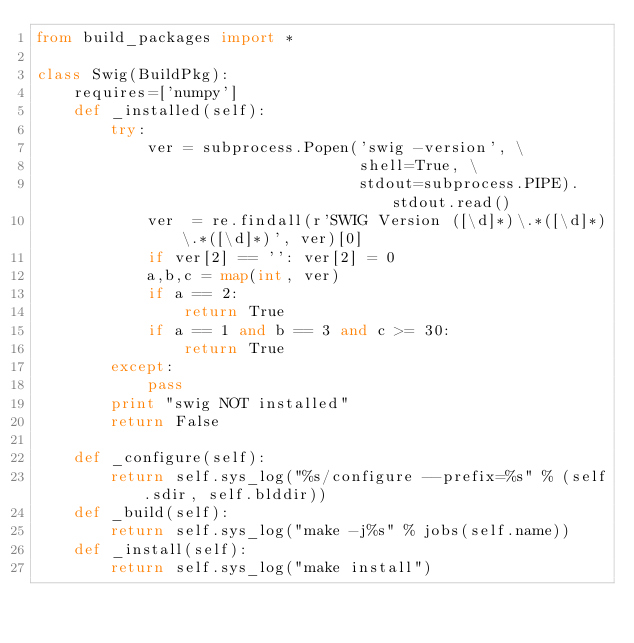<code> <loc_0><loc_0><loc_500><loc_500><_Python_>from build_packages import *

class Swig(BuildPkg):
    requires=['numpy']
    def _installed(self):
        try:
            ver = subprocess.Popen('swig -version', \
                                   shell=True, \
                                   stdout=subprocess.PIPE).stdout.read()
            ver  = re.findall(r'SWIG Version ([\d]*)\.*([\d]*)\.*([\d]*)', ver)[0]
            if ver[2] == '': ver[2] = 0
            a,b,c = map(int, ver)
            if a == 2:
                return True
            if a == 1 and b == 3 and c >= 30:
                return True
        except:
            pass
        print "swig NOT installed"        
        return False

    def _configure(self):
        return self.sys_log("%s/configure --prefix=%s" % (self.sdir, self.blddir))
    def _build(self):
        return self.sys_log("make -j%s" % jobs(self.name))
    def _install(self):
        return self.sys_log("make install")
</code> 